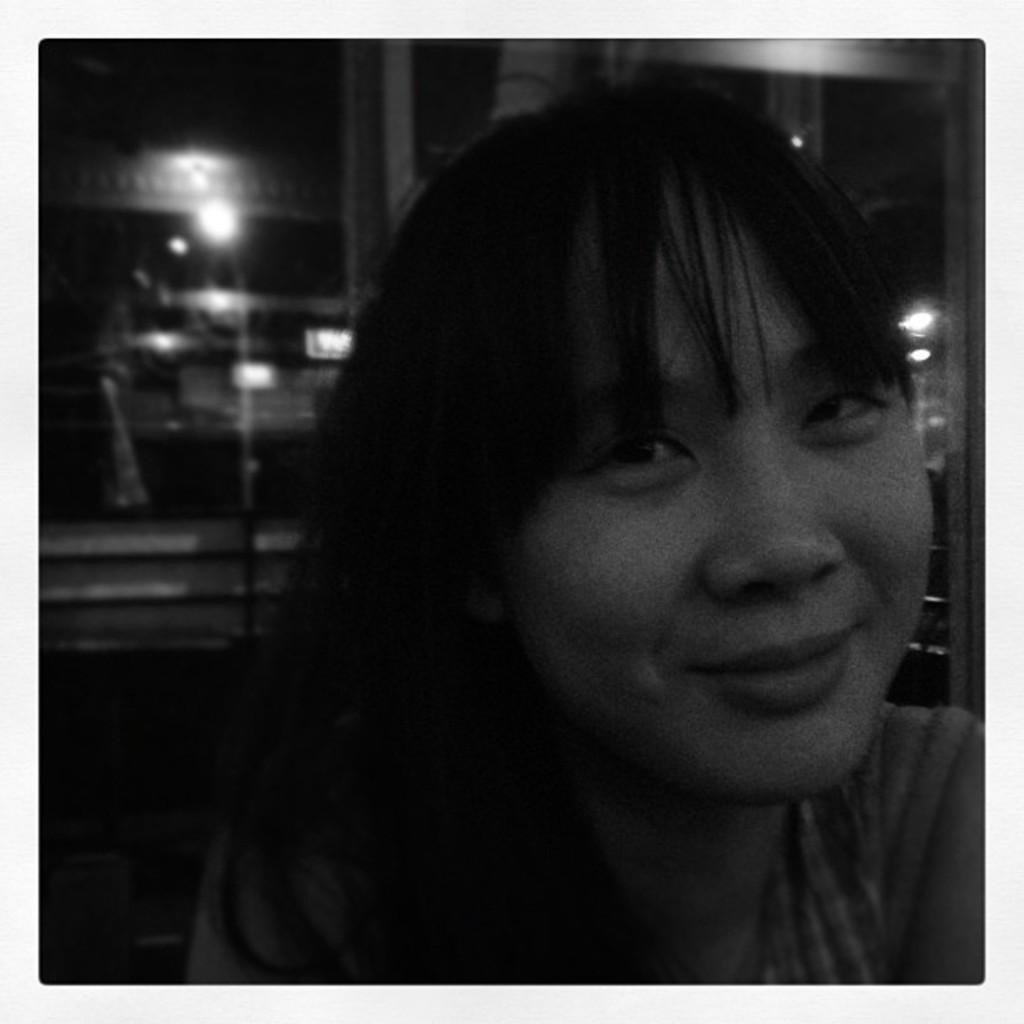What is present in the image? There is a person in the image. What can be seen in the background of the image? There are lights visible in the background of the image. How is the image presented in terms of color? The image is in black and white. What type of sofa can be seen in the image? There is no sofa present in the image. How does the person in the image stretch their arms? The image does not show the person stretching their arms, so it cannot be determined from the picture. 